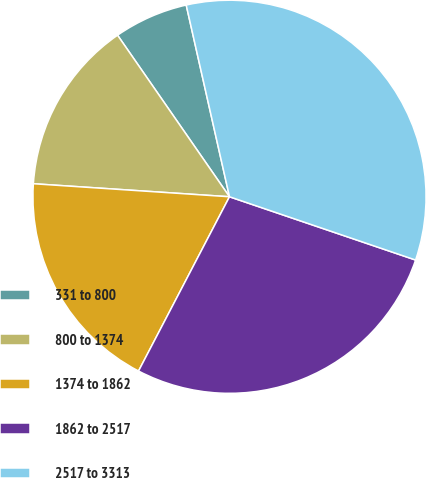<chart> <loc_0><loc_0><loc_500><loc_500><pie_chart><fcel>331 to 800<fcel>800 to 1374<fcel>1374 to 1862<fcel>1862 to 2517<fcel>2517 to 3313<nl><fcel>6.11%<fcel>14.3%<fcel>18.4%<fcel>27.44%<fcel>33.75%<nl></chart> 